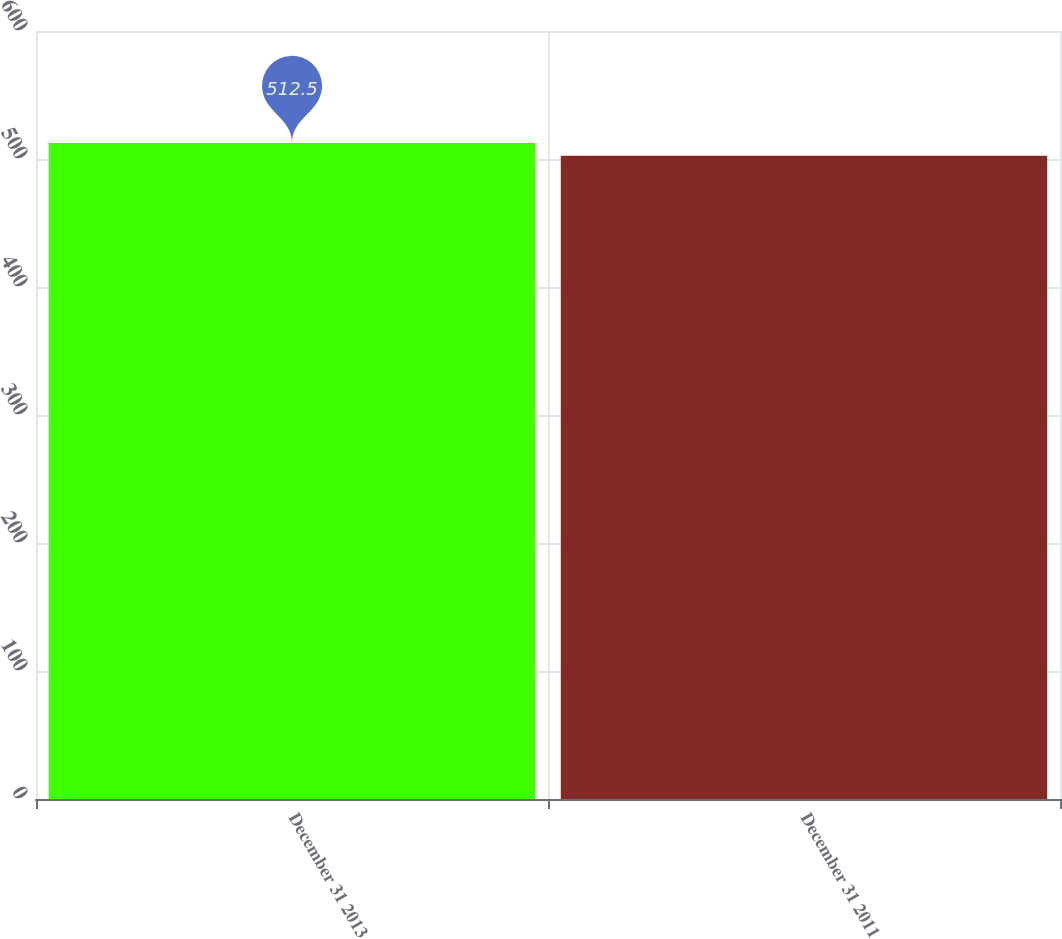Convert chart. <chart><loc_0><loc_0><loc_500><loc_500><bar_chart><fcel>December 31 2013<fcel>December 31 2011<nl><fcel>512.5<fcel>502.5<nl></chart> 